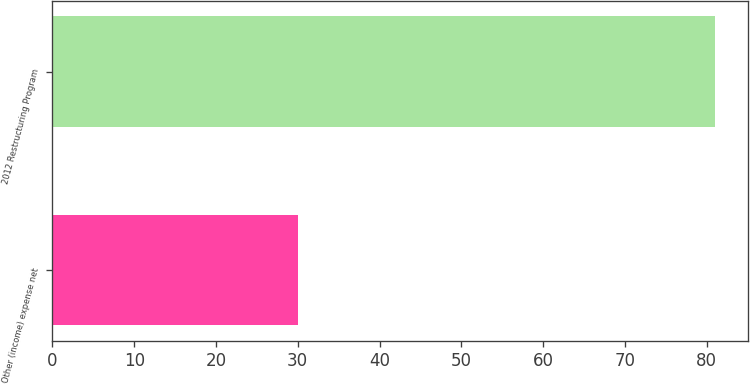Convert chart to OTSL. <chart><loc_0><loc_0><loc_500><loc_500><bar_chart><fcel>Other (income) expense net<fcel>2012 Restructuring Program<nl><fcel>30<fcel>81<nl></chart> 